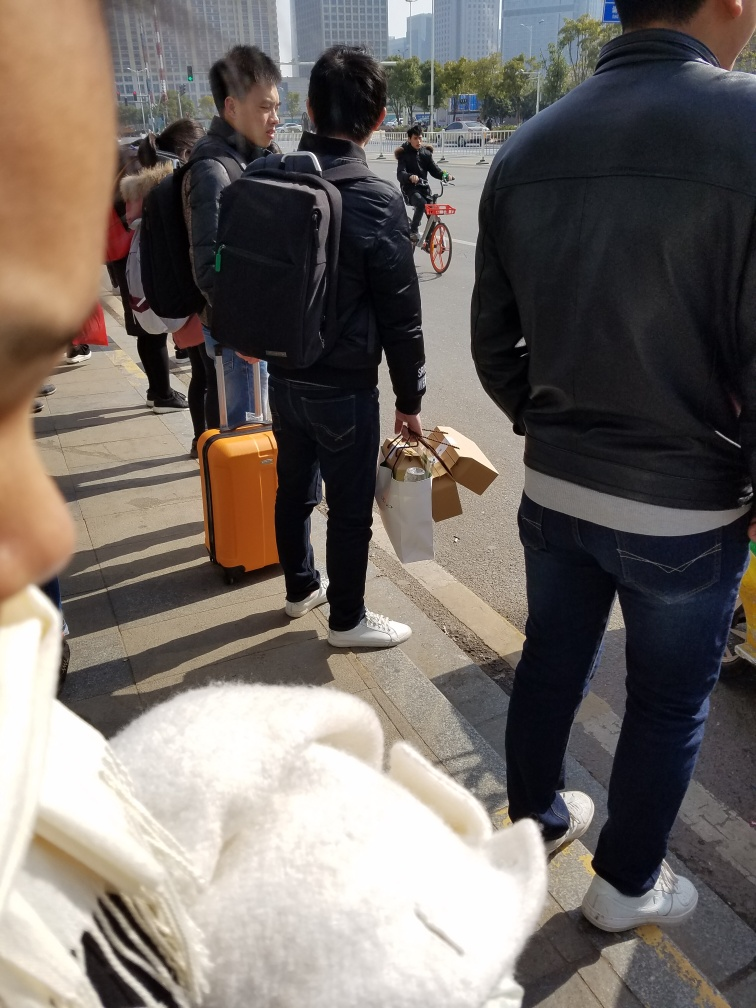Are there any obstructions blocking part of the frame? Yes, there are obstructions in the frame, primarily along the edges which include portions of human figures that are cut-off, likely due to the camera angle and the photographer's proximity to the subjects. 